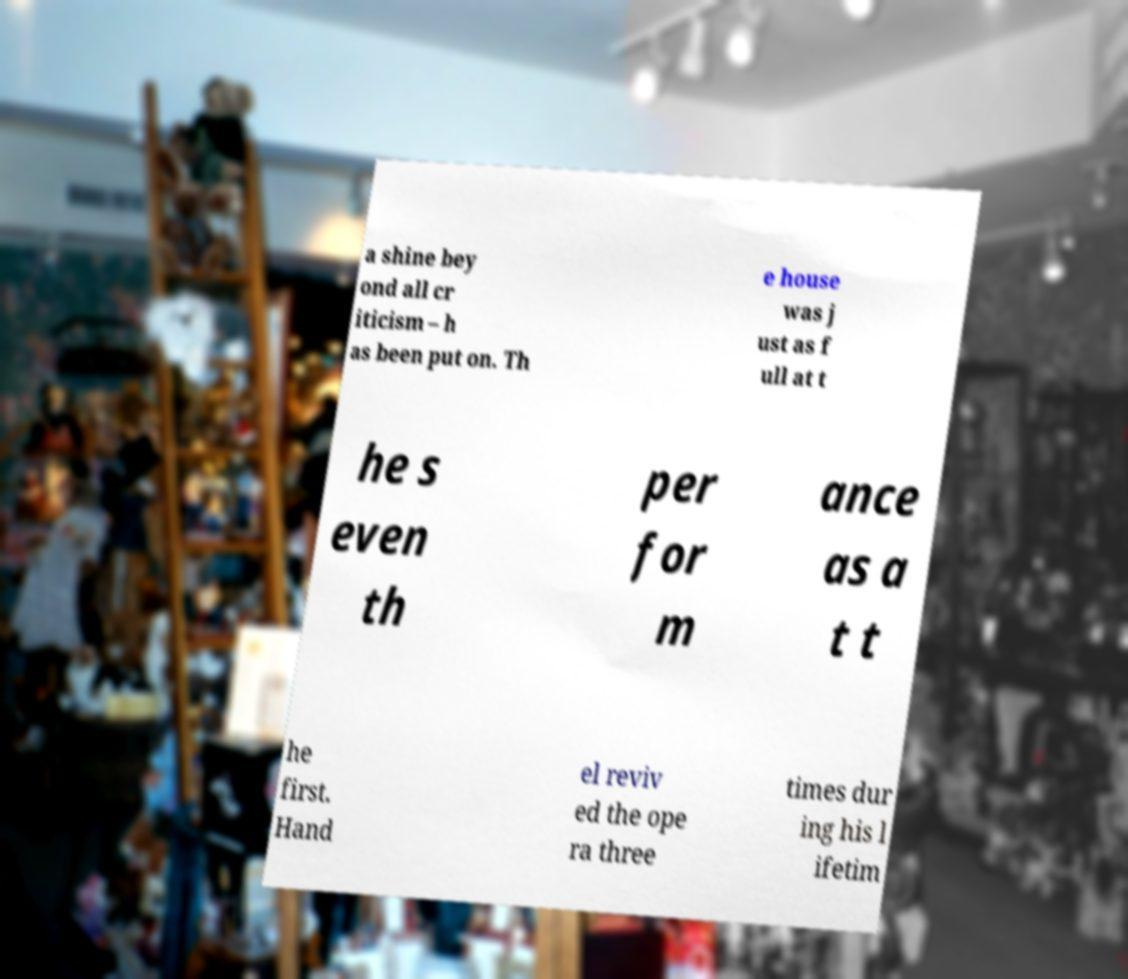Could you assist in decoding the text presented in this image and type it out clearly? a shine bey ond all cr iticism – h as been put on. Th e house was j ust as f ull at t he s even th per for m ance as a t t he first. Hand el reviv ed the ope ra three times dur ing his l ifetim 